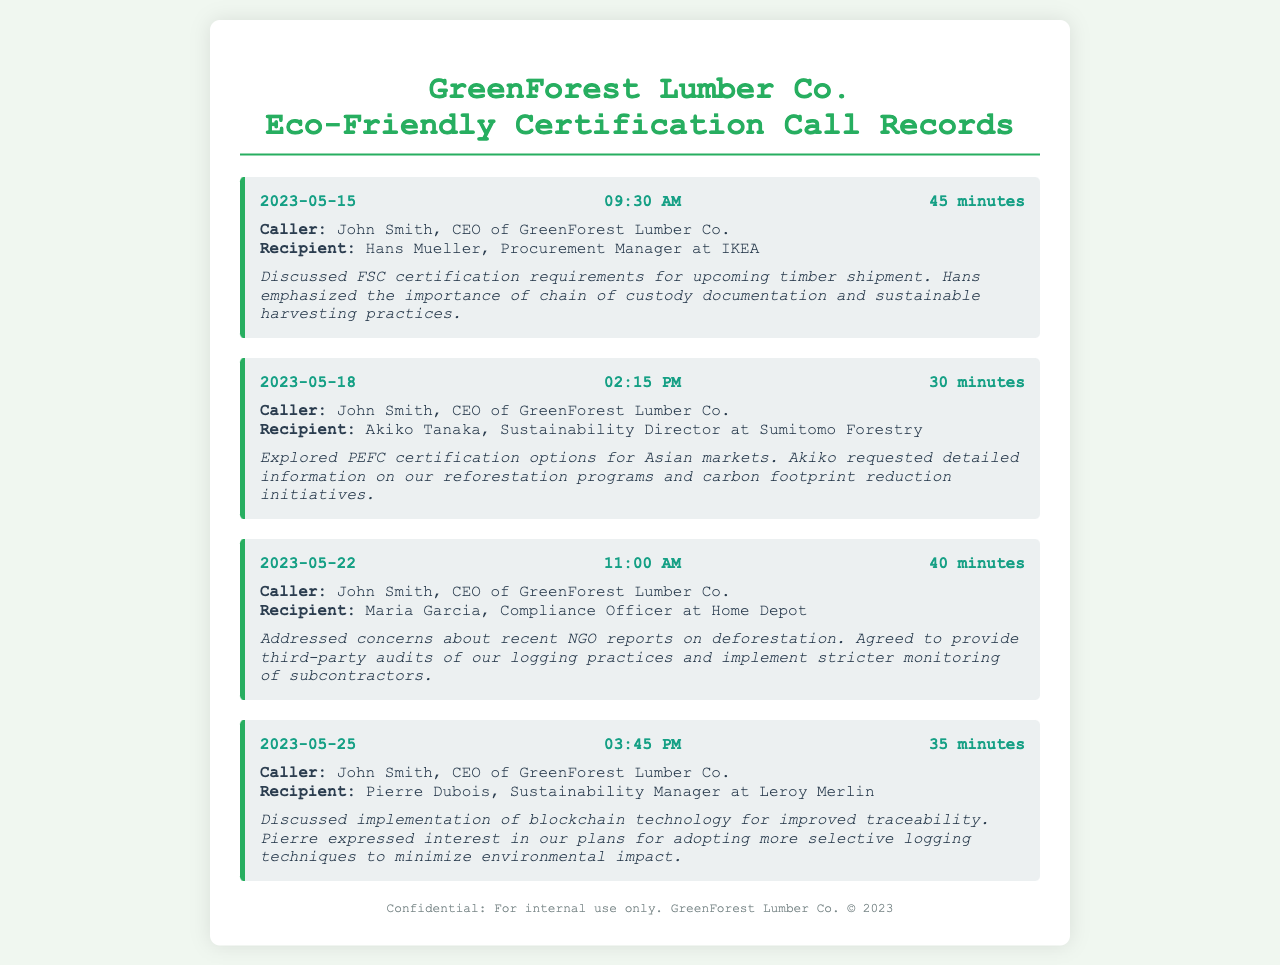What was the date of the first call? The first call took place on May 15, 2023.
Answer: May 15, 2023 Who was the recipient of the call on May 18, 2023? The recipient of the May 18 call was Akiko Tanaka.
Answer: Akiko Tanaka What sustainability certification was discussed with Hans Mueller? The certification discussed with Hans Mueller was FSC certification.
Answer: FSC certification How long did the call with Maria Garcia last? The call with Maria Garcia lasted for 40 minutes.
Answer: 40 minutes What did Akiko request information on during the call? Akiko requested detailed information on reforestation programs and carbon footprint reduction initiatives.
Answer: Reforestation programs and carbon footprint reduction initiatives Which technology was discussed for improved traceability? The technology discussed for improved traceability was blockchain technology.
Answer: Blockchain technology How many minutes was the call with Pierre Dubois? The call with Pierre Dubois lasted for 35 minutes.
Answer: 35 minutes What was agreed upon in the call with Maria Garcia? It was agreed to provide third-party audits of logging practices.
Answer: Third-party audits of logging practices Who is the caller in all the recorded calls? The caller in all recorded calls is John Smith.
Answer: John Smith 